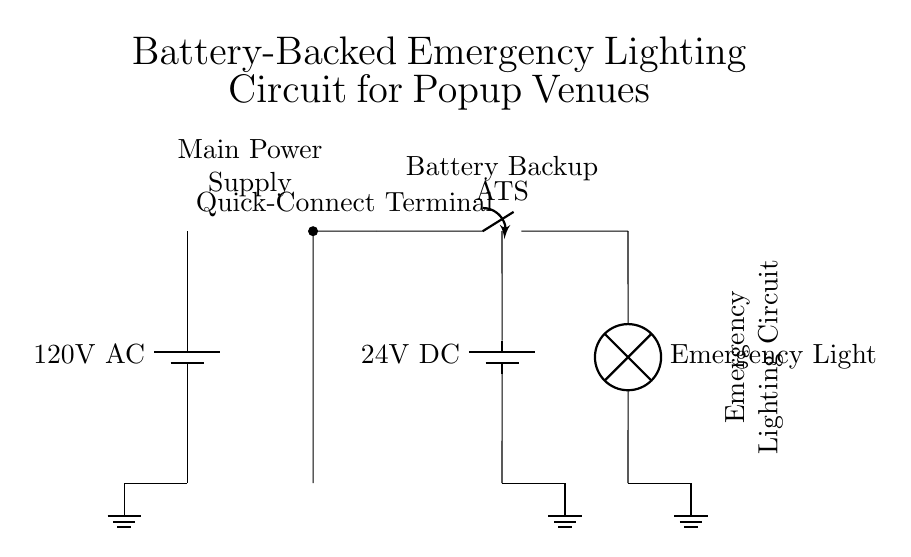What is the main power supply voltage? The main power supply voltage, indicated in the circuit, is shown next to the battery symbol. It specifies that the voltage is 120 volts alternating current.
Answer: 120 volts AC What type of switch is used for the battery-backed circuit? The type of switch used is labeled as an ATS, which stands for automatic transfer switch. This is indicated in the circuit next to the connection for emergency lighting.
Answer: ATS What is the backup voltage of the battery? The backup battery voltage is specified next to the battery symbol in the circuit. It indicates that the battery provides 24 volts direct current.
Answer: 24 volts DC What does the terminal labeled "Quick-Connect" imply? The "Quick-Connect" terminal is a connection point designed for easy and fast connection to emergency lighting, facilitating a swift setup in popup venues.
Answer: Easy connection How does the emergency lighting receive power during a power failure? The emergency lighting receives power from the battery backup through the automatic transfer switch when the main power supply fails, as shown by the connections in the circuit. This means when the main supply is cut, the ATS switches the load to the battery.
Answer: Through ATS What type of lighting is represented in the circuit diagram? The circuit diagram represents emergency lighting, specifically indicated by the label "Emergency Light" next to the lamp symbol. This lighting is intended to provide illumination during power outages or emergencies.
Answer: Emergency Light What is the purpose of the ground connections? The ground connections provide safety by directing excess current safely into the ground, protecting the circuit and users from electrical faults. In the circuit, ground symbols are placed at different points indicating grounding connections for the main supply, battery, and emergency light.
Answer: Safety grounding 